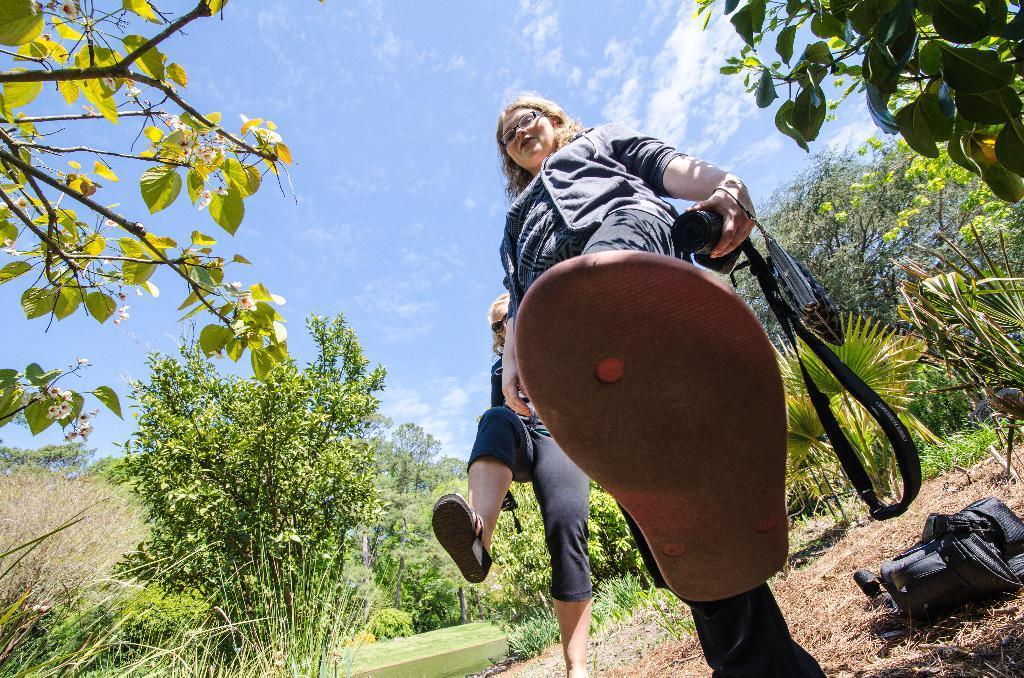Can you describe this image briefly? In this picture we can see a woman wearing a spectacle and holding a camera in her hand. We can see the purse and a person wearing goggles. There is some grass, a bag and a few plants are visible on the ground. We can see a few trees. There is the sky and the clouds. 